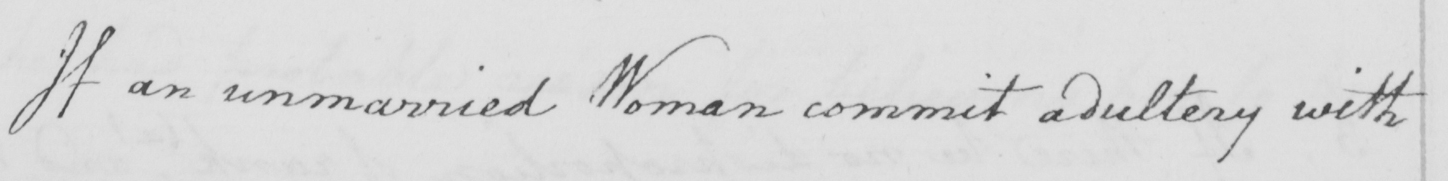Please provide the text content of this handwritten line. If an unmarried Woman commit adultery with 